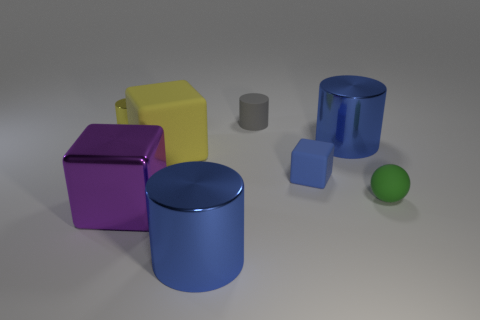Among the objects presented, which one appears to be the largest? The largest object in the image appears to be the purple cube, given its dimensions relative to the other objects. What could be the use of this purple cube in real life? In real life, the purple cube could be a storage box, a decorative piece, or even a child's oversized toy block, depending on its actual size and material. 